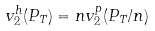Convert formula to latex. <formula><loc_0><loc_0><loc_500><loc_500>v _ { 2 } ^ { h } ( P _ { T } ) = n v _ { 2 } ^ { p } ( P _ { T } / n )</formula> 